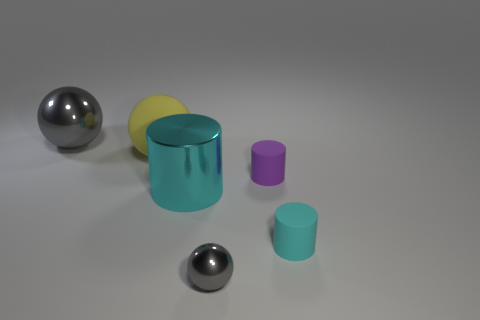How do the sizes of the objects compare to one another? The objects in the image vary in size. The large cyan cylinder is the tallest, followed by the yellow cylinder which is shorter in height. The purple cylinder is even smaller, and the two spheres appear to be of different sizes, with one being quite small in comparison to the other objects. 